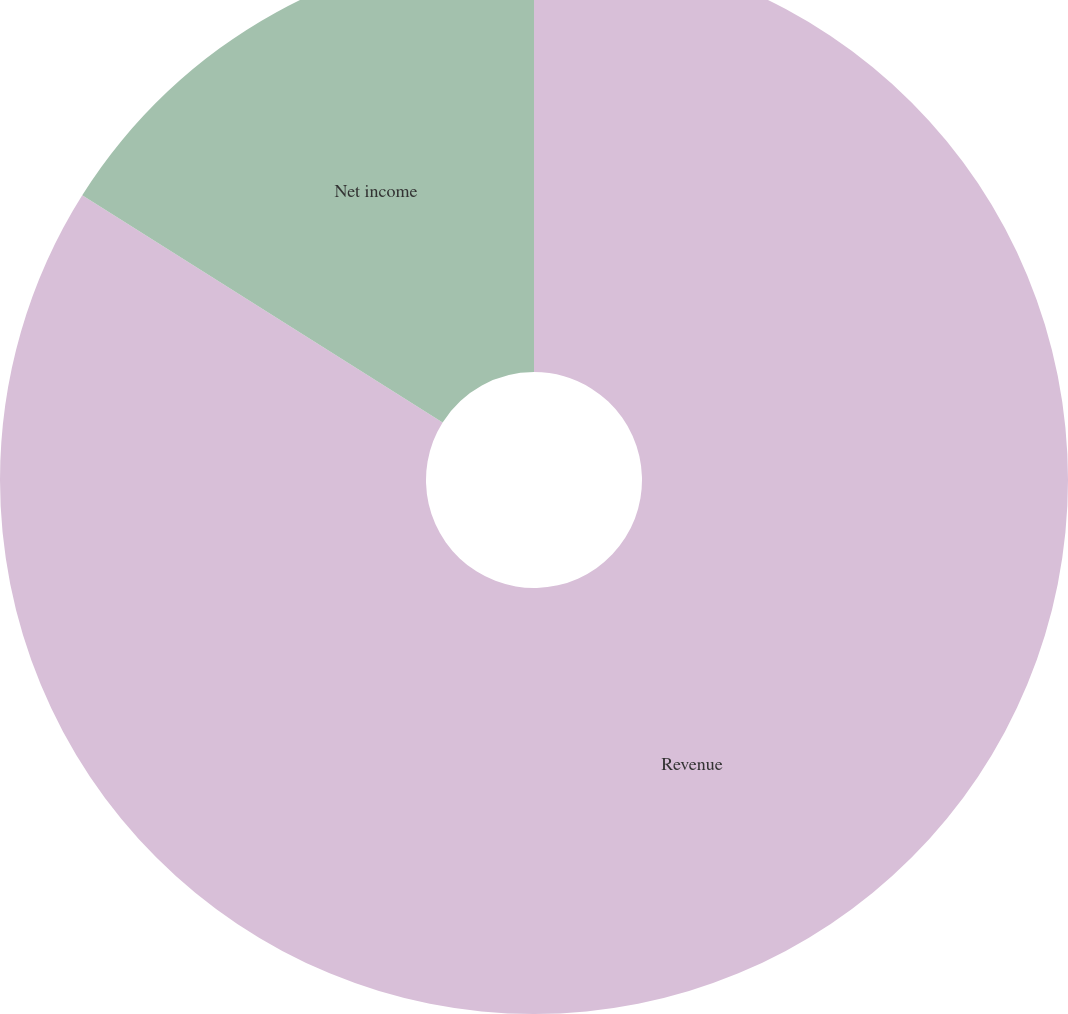Convert chart to OTSL. <chart><loc_0><loc_0><loc_500><loc_500><pie_chart><fcel>Revenue<fcel>Net income<nl><fcel>83.95%<fcel>16.05%<nl></chart> 